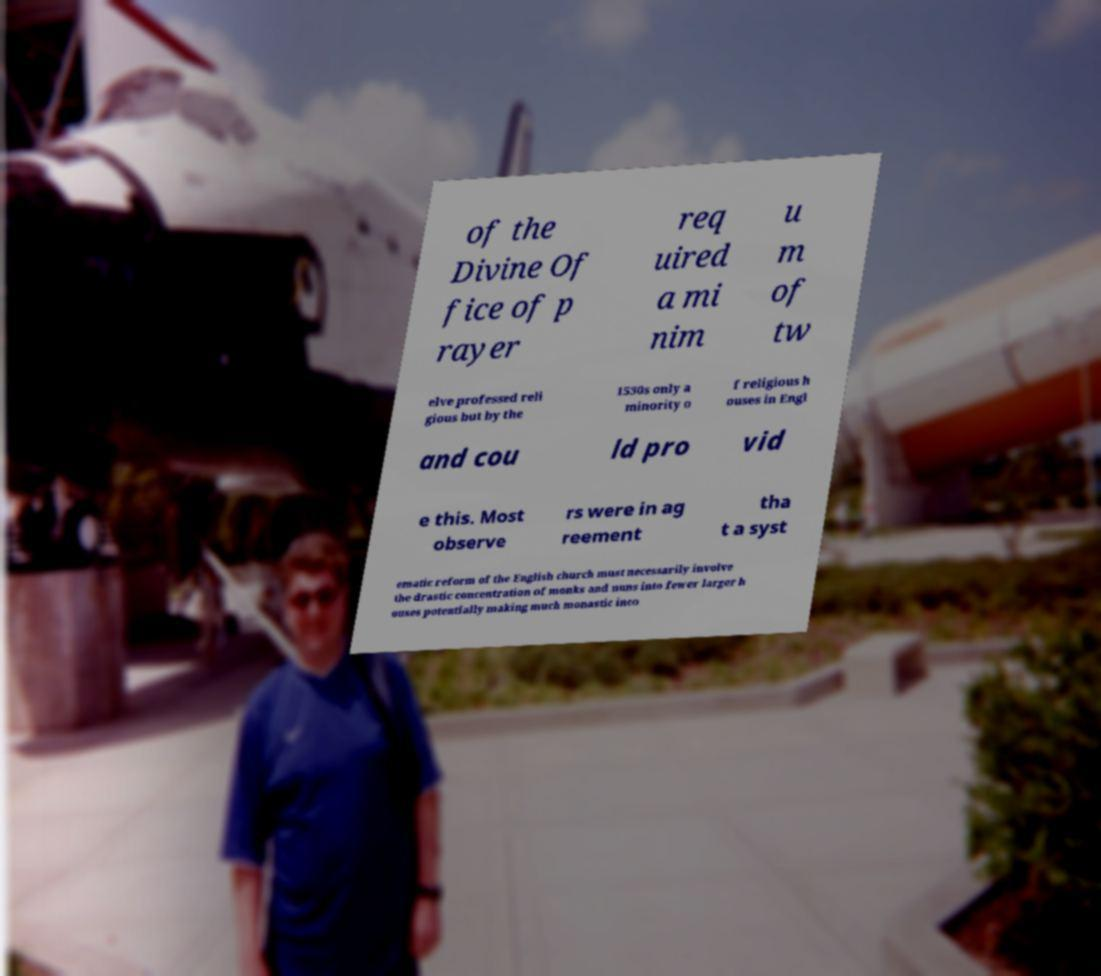Could you assist in decoding the text presented in this image and type it out clearly? of the Divine Of fice of p rayer req uired a mi nim u m of tw elve professed reli gious but by the 1530s only a minority o f religious h ouses in Engl and cou ld pro vid e this. Most observe rs were in ag reement tha t a syst ematic reform of the English church must necessarily involve the drastic concentration of monks and nuns into fewer larger h ouses potentially making much monastic inco 